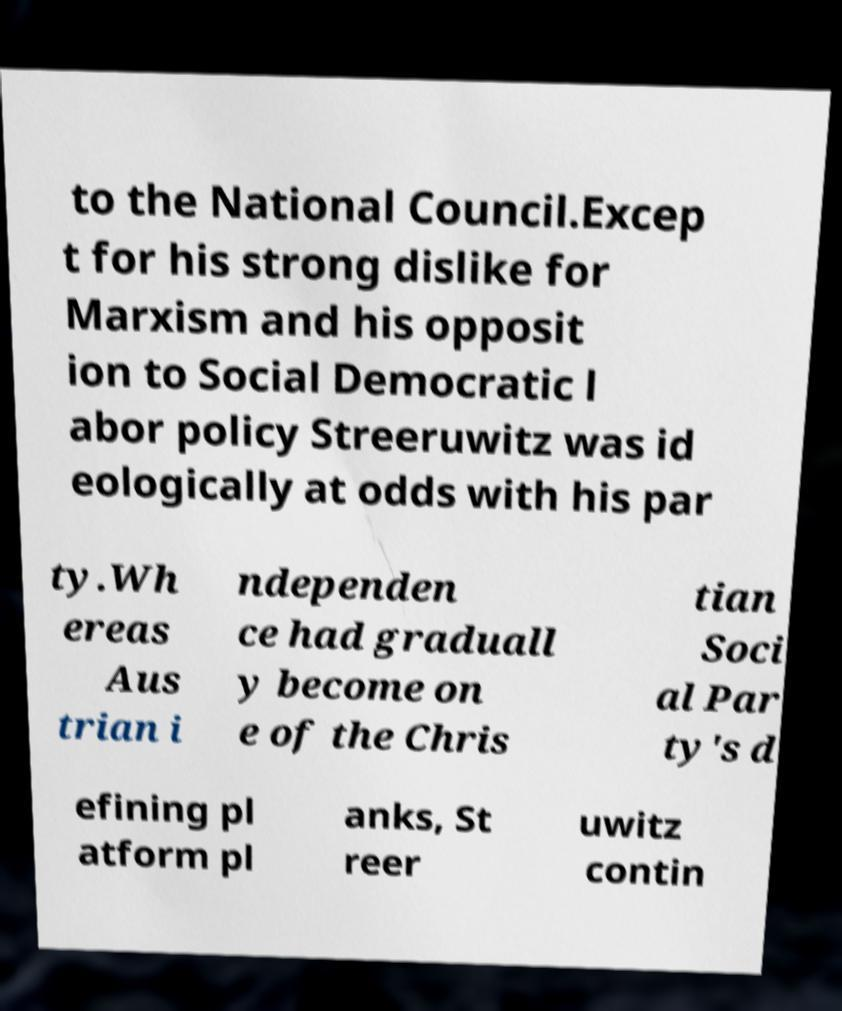There's text embedded in this image that I need extracted. Can you transcribe it verbatim? to the National Council.Excep t for his strong dislike for Marxism and his opposit ion to Social Democratic l abor policy Streeruwitz was id eologically at odds with his par ty.Wh ereas Aus trian i ndependen ce had graduall y become on e of the Chris tian Soci al Par ty's d efining pl atform pl anks, St reer uwitz contin 